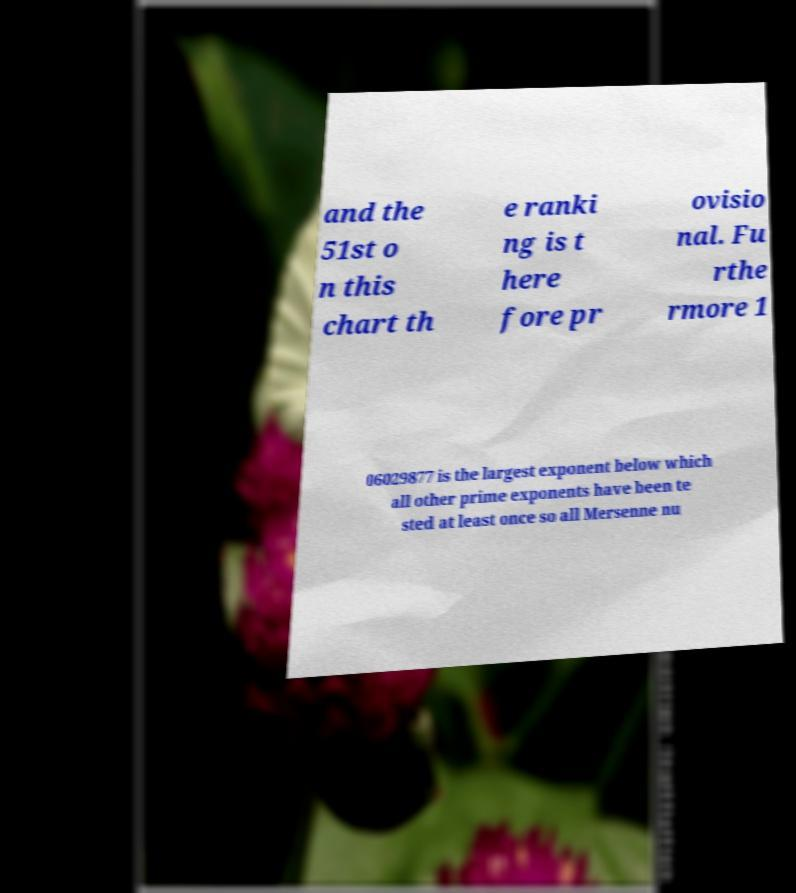Could you assist in decoding the text presented in this image and type it out clearly? and the 51st o n this chart th e ranki ng is t here fore pr ovisio nal. Fu rthe rmore 1 06029877 is the largest exponent below which all other prime exponents have been te sted at least once so all Mersenne nu 